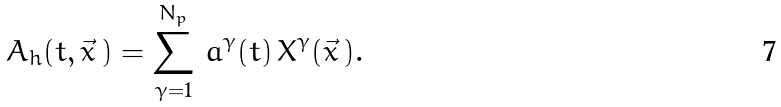Convert formula to latex. <formula><loc_0><loc_0><loc_500><loc_500>A _ { h } ( t , \vec { x } \, ) = \sum _ { \gamma = 1 } ^ { N _ { p } } \, a ^ { \gamma } ( t ) \, X ^ { \gamma } ( \vec { x } \, ) .</formula> 